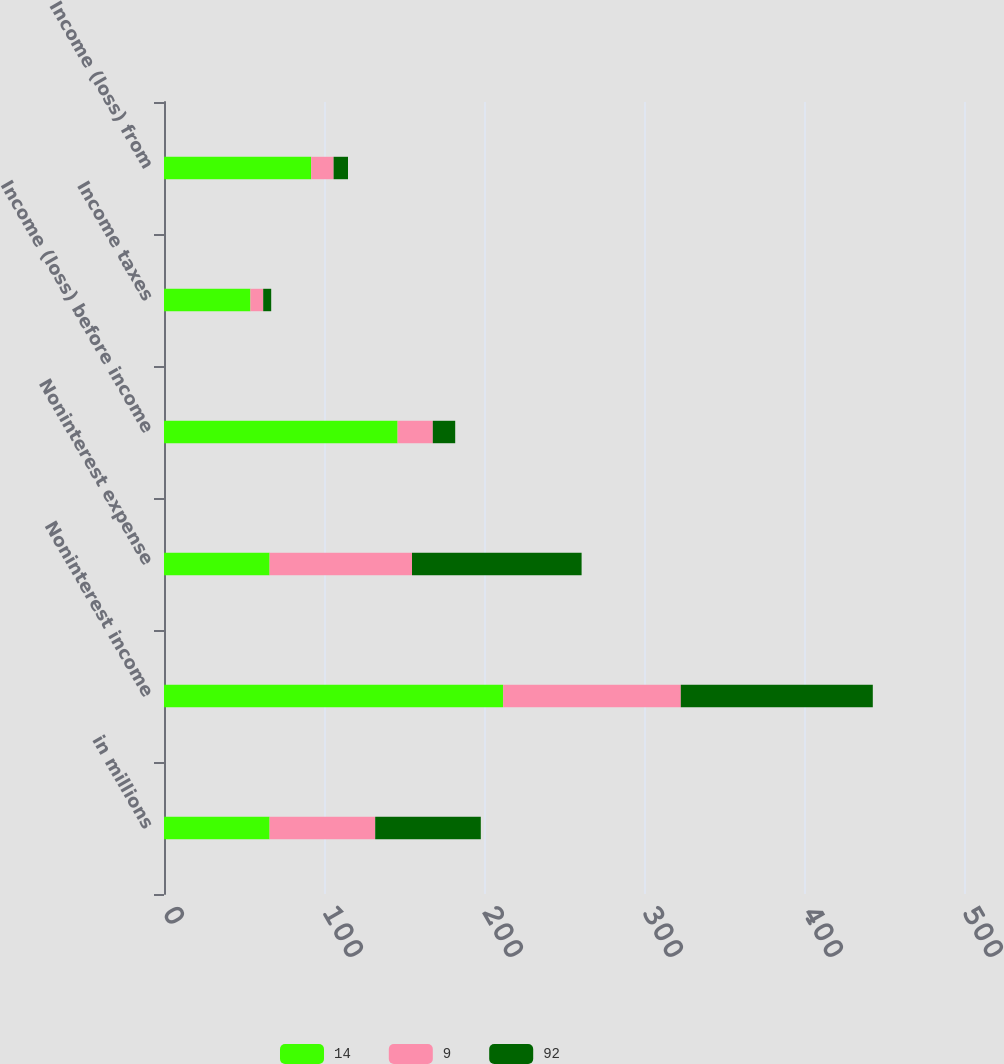<chart> <loc_0><loc_0><loc_500><loc_500><stacked_bar_chart><ecel><fcel>in millions<fcel>Noninterest income<fcel>Noninterest expense<fcel>Income (loss) before income<fcel>Income taxes<fcel>Income (loss) from<nl><fcel>14<fcel>66<fcel>212<fcel>66<fcel>146<fcel>54<fcel>92<nl><fcel>9<fcel>66<fcel>111<fcel>89<fcel>22<fcel>8<fcel>14<nl><fcel>92<fcel>66<fcel>120<fcel>106<fcel>14<fcel>5<fcel>9<nl></chart> 